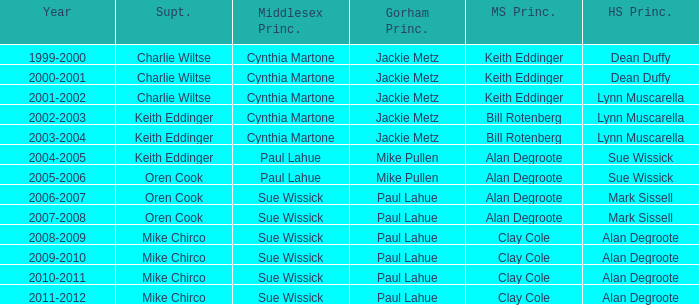Write the full table. {'header': ['Year', 'Supt.', 'Middlesex Princ.', 'Gorham Princ.', 'MS Princ.', 'HS Princ.'], 'rows': [['1999-2000', 'Charlie Wiltse', 'Cynthia Martone', 'Jackie Metz', 'Keith Eddinger', 'Dean Duffy'], ['2000-2001', 'Charlie Wiltse', 'Cynthia Martone', 'Jackie Metz', 'Keith Eddinger', 'Dean Duffy'], ['2001-2002', 'Charlie Wiltse', 'Cynthia Martone', 'Jackie Metz', 'Keith Eddinger', 'Lynn Muscarella'], ['2002-2003', 'Keith Eddinger', 'Cynthia Martone', 'Jackie Metz', 'Bill Rotenberg', 'Lynn Muscarella'], ['2003-2004', 'Keith Eddinger', 'Cynthia Martone', 'Jackie Metz', 'Bill Rotenberg', 'Lynn Muscarella'], ['2004-2005', 'Keith Eddinger', 'Paul Lahue', 'Mike Pullen', 'Alan Degroote', 'Sue Wissick'], ['2005-2006', 'Oren Cook', 'Paul Lahue', 'Mike Pullen', 'Alan Degroote', 'Sue Wissick'], ['2006-2007', 'Oren Cook', 'Sue Wissick', 'Paul Lahue', 'Alan Degroote', 'Mark Sissell'], ['2007-2008', 'Oren Cook', 'Sue Wissick', 'Paul Lahue', 'Alan Degroote', 'Mark Sissell'], ['2008-2009', 'Mike Chirco', 'Sue Wissick', 'Paul Lahue', 'Clay Cole', 'Alan Degroote'], ['2009-2010', 'Mike Chirco', 'Sue Wissick', 'Paul Lahue', 'Clay Cole', 'Alan Degroote'], ['2010-2011', 'Mike Chirco', 'Sue Wissick', 'Paul Lahue', 'Clay Cole', 'Alan Degroote'], ['2011-2012', 'Mike Chirco', 'Sue Wissick', 'Paul Lahue', 'Clay Cole', 'Alan Degroote']]} How many years was lynn muscarella the high school principal and charlie wiltse the superintendent? 1.0. 